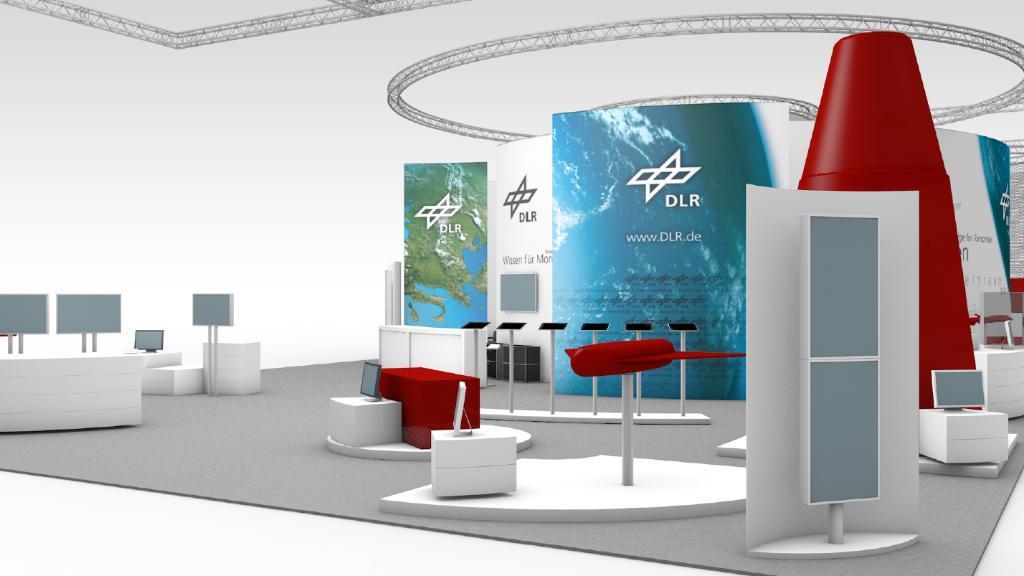Please provide a concise description of this image. There are tables. On the tables there are systems. Also there are some boards with stands. In the back there are posters. Also there are some red color objects. 